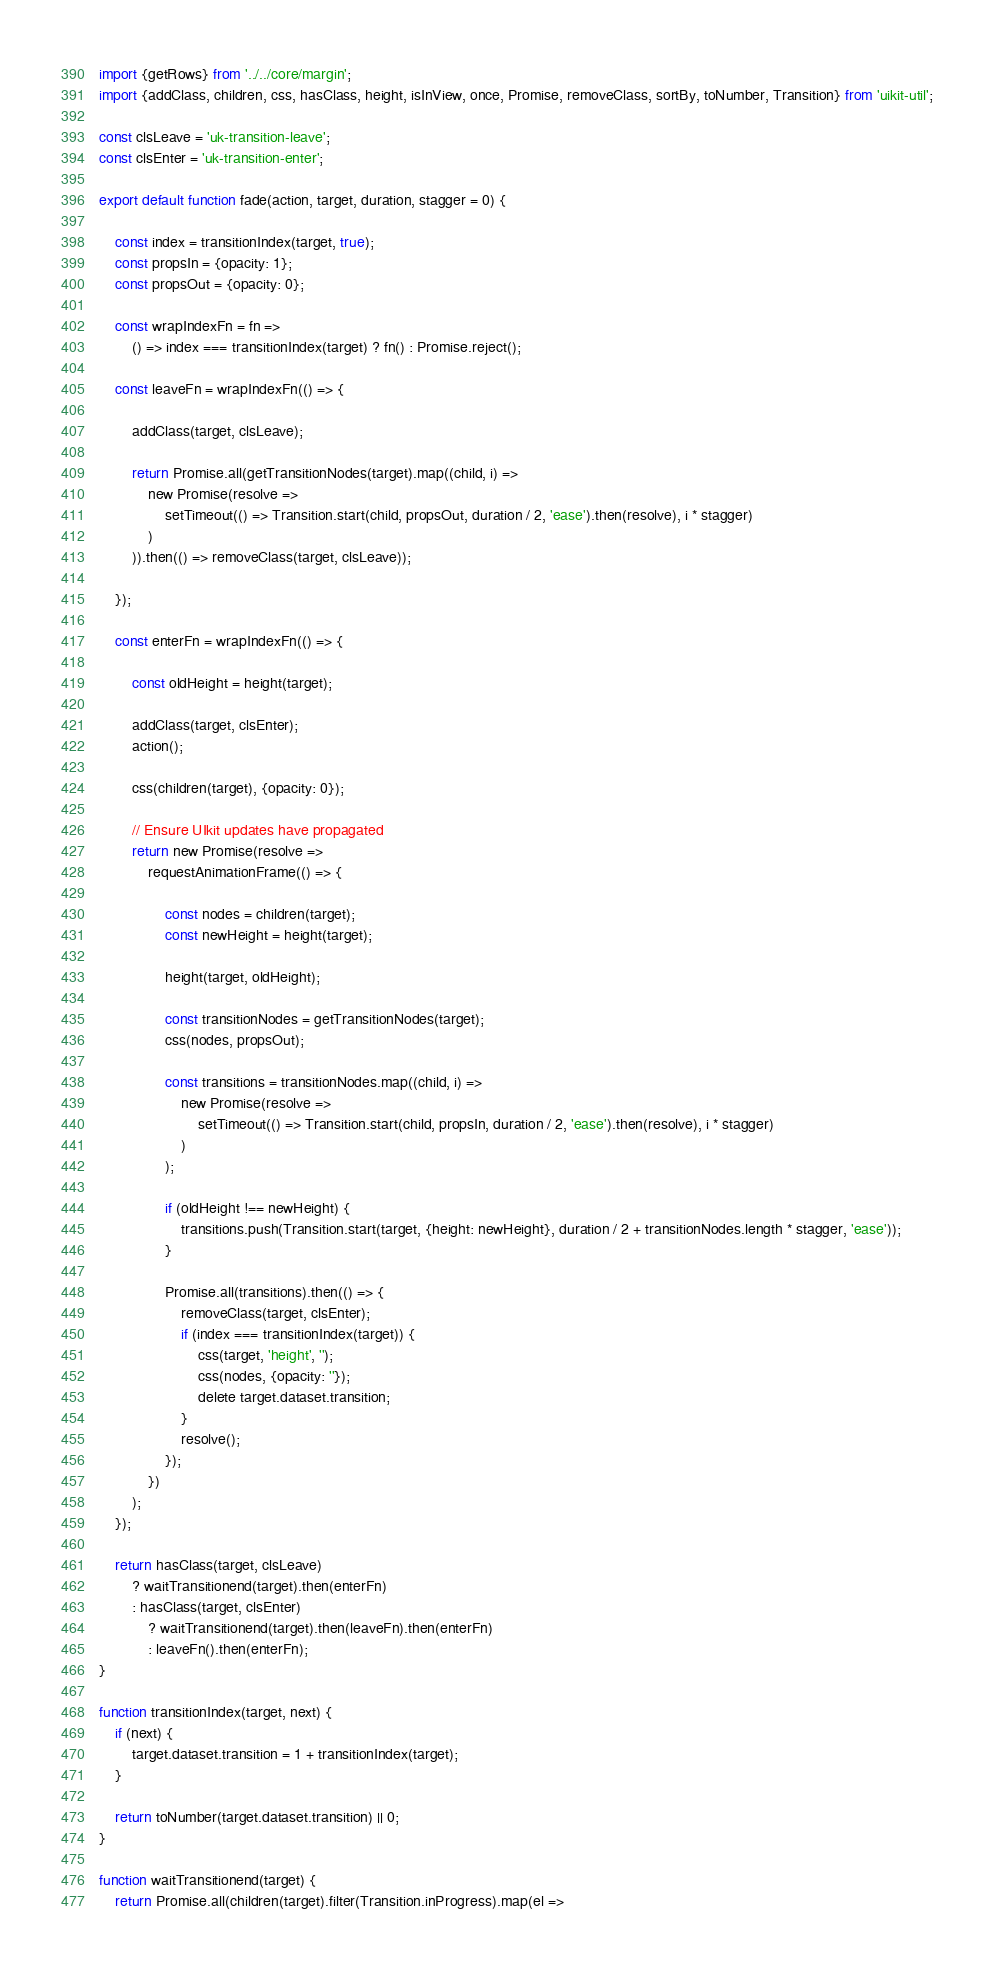<code> <loc_0><loc_0><loc_500><loc_500><_JavaScript_>import {getRows} from '../../core/margin';
import {addClass, children, css, hasClass, height, isInView, once, Promise, removeClass, sortBy, toNumber, Transition} from 'uikit-util';

const clsLeave = 'uk-transition-leave';
const clsEnter = 'uk-transition-enter';

export default function fade(action, target, duration, stagger = 0) {

    const index = transitionIndex(target, true);
    const propsIn = {opacity: 1};
    const propsOut = {opacity: 0};

    const wrapIndexFn = fn =>
        () => index === transitionIndex(target) ? fn() : Promise.reject();

    const leaveFn = wrapIndexFn(() => {

        addClass(target, clsLeave);

        return Promise.all(getTransitionNodes(target).map((child, i) =>
            new Promise(resolve =>
                setTimeout(() => Transition.start(child, propsOut, duration / 2, 'ease').then(resolve), i * stagger)
            )
        )).then(() => removeClass(target, clsLeave));

    });

    const enterFn = wrapIndexFn(() => {

        const oldHeight = height(target);

        addClass(target, clsEnter);
        action();

        css(children(target), {opacity: 0});

        // Ensure UIkit updates have propagated
        return new Promise(resolve =>
            requestAnimationFrame(() => {

                const nodes = children(target);
                const newHeight = height(target);

                height(target, oldHeight);

                const transitionNodes = getTransitionNodes(target);
                css(nodes, propsOut);

                const transitions = transitionNodes.map((child, i) =>
                    new Promise(resolve =>
                        setTimeout(() => Transition.start(child, propsIn, duration / 2, 'ease').then(resolve), i * stagger)
                    )
                );

                if (oldHeight !== newHeight) {
                    transitions.push(Transition.start(target, {height: newHeight}, duration / 2 + transitionNodes.length * stagger, 'ease'));
                }

                Promise.all(transitions).then(() => {
                    removeClass(target, clsEnter);
                    if (index === transitionIndex(target)) {
                        css(target, 'height', '');
                        css(nodes, {opacity: ''});
                        delete target.dataset.transition;
                    }
                    resolve();
                });
            })
        );
    });

    return hasClass(target, clsLeave)
        ? waitTransitionend(target).then(enterFn)
        : hasClass(target, clsEnter)
            ? waitTransitionend(target).then(leaveFn).then(enterFn)
            : leaveFn().then(enterFn);
}

function transitionIndex(target, next) {
    if (next) {
        target.dataset.transition = 1 + transitionIndex(target);
    }

    return toNumber(target.dataset.transition) || 0;
}

function waitTransitionend(target) {
    return Promise.all(children(target).filter(Transition.inProgress).map(el =></code> 